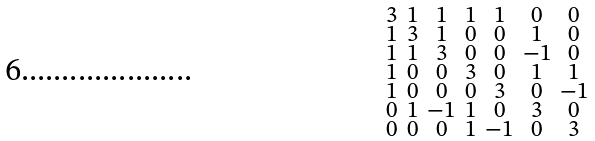Convert formula to latex. <formula><loc_0><loc_0><loc_500><loc_500>\begin{smallmatrix} 3 & 1 & 1 & 1 & 1 & 0 & 0 \\ 1 & 3 & 1 & 0 & 0 & 1 & 0 \\ 1 & 1 & 3 & 0 & 0 & - 1 & 0 \\ 1 & 0 & 0 & 3 & 0 & 1 & 1 \\ 1 & 0 & 0 & 0 & 3 & 0 & - 1 \\ 0 & 1 & - 1 & 1 & 0 & 3 & 0 \\ 0 & 0 & 0 & 1 & - 1 & 0 & 3 \end{smallmatrix}</formula> 